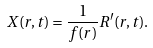<formula> <loc_0><loc_0><loc_500><loc_500>X ( r , t ) = \frac { 1 } { f ( r ) } R ^ { \prime } ( r , t ) .</formula> 